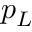<formula> <loc_0><loc_0><loc_500><loc_500>p _ { L }</formula> 